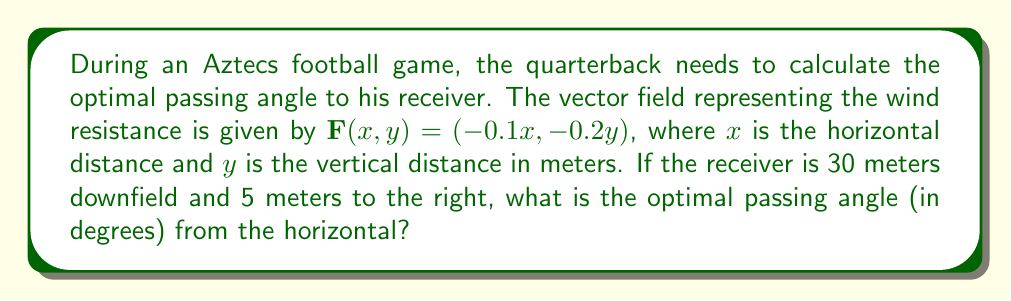Help me with this question. To find the optimal passing angle, we'll follow these steps:

1) The vector field $\mathbf{F}(x,y) = (-0.1x, -0.2y)$ represents the wind resistance. The optimal path will be the one that minimizes the effect of this resistance.

2) In a dynamical system, the path of least resistance is often represented by the nullclines of the system. The nullclines are where the components of the vector field are zero.

3) For this system, the nullclines are:
   $-0.1x = 0 \implies x = 0$
   $-0.2y = 0 \implies y = 0$

4) The intersection of these nullclines (0,0) is a fixed point of the system, but it's not relevant for our problem.

5) The optimal path will be the one that stays closest to these nullclines while reaching the target point.

6) Given that the receiver is 30 meters downfield and 5 meters to the right, the target point is (30, 5).

7) The straight line from (0,0) to (30,5) will be close to optimal, as it minimizes the distance traveled while staying relatively close to the nullclines.

8) To find the angle of this line, we can use the arctangent function:

   $\theta = \arctan(\frac{y}{x}) = \arctan(\frac{5}{30})$

9) Convert this to degrees:

   $\theta = \arctan(\frac{1}{6}) \cdot \frac{180}{\pi} \approx 9.46°$

This angle represents the optimal passing angle from the horizontal.
Answer: $9.46°$ 